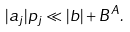Convert formula to latex. <formula><loc_0><loc_0><loc_500><loc_500>| a _ { j } | p _ { j } \ll | b | + B ^ { A } .</formula> 